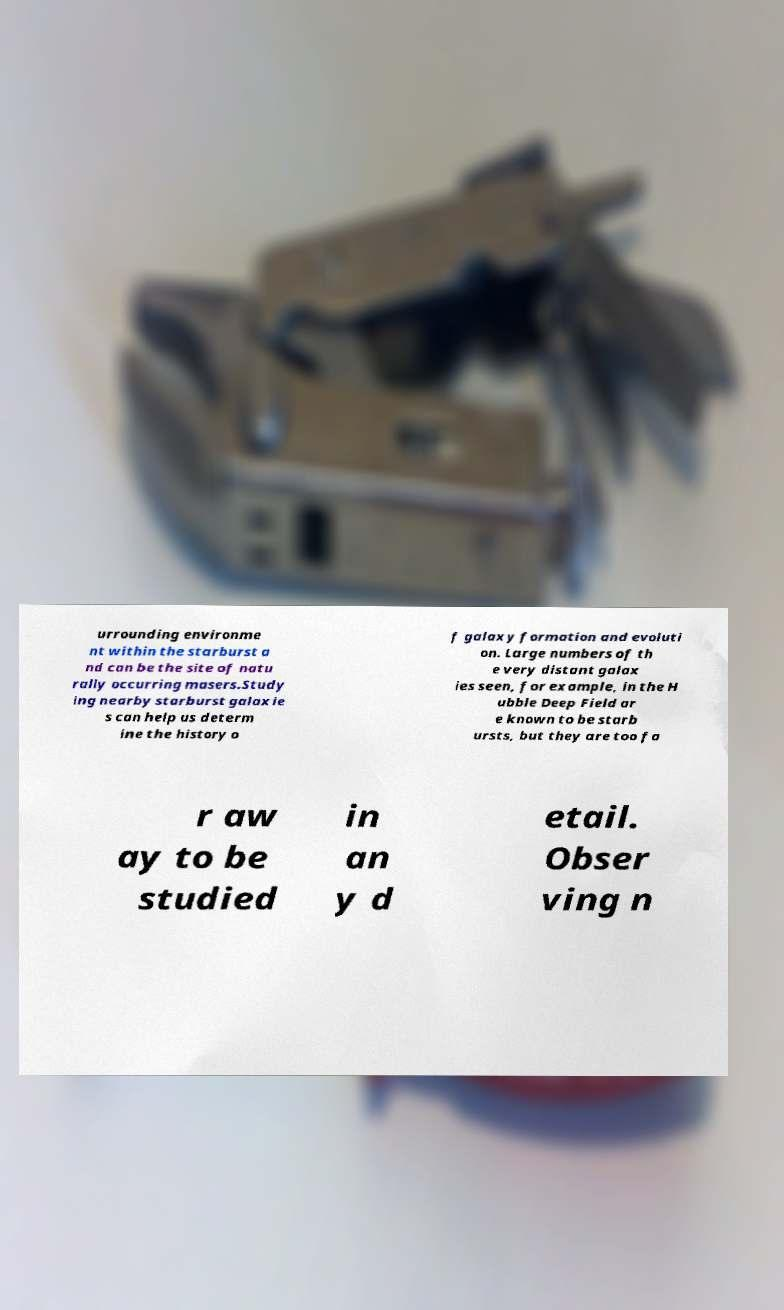Could you assist in decoding the text presented in this image and type it out clearly? urrounding environme nt within the starburst a nd can be the site of natu rally occurring masers.Study ing nearby starburst galaxie s can help us determ ine the history o f galaxy formation and evoluti on. Large numbers of th e very distant galax ies seen, for example, in the H ubble Deep Field ar e known to be starb ursts, but they are too fa r aw ay to be studied in an y d etail. Obser ving n 